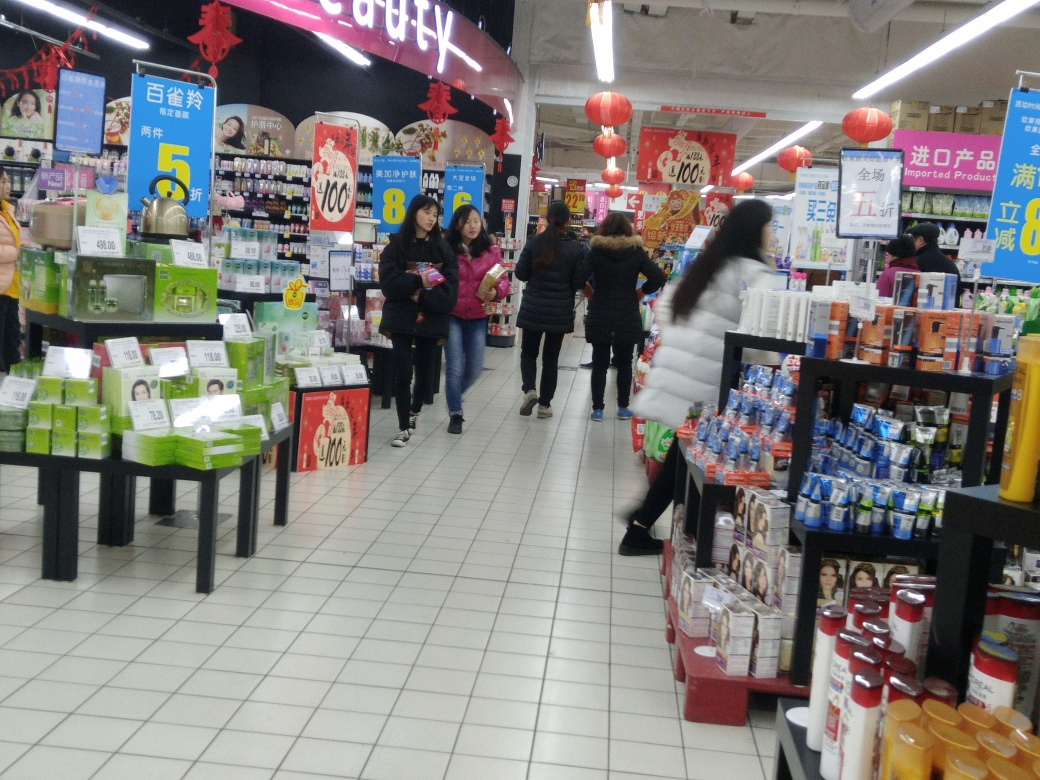Is the image completely free of motion blur? Upon close examination, the image does show slight signs of motion blur, particularly around moving subjects such as the people walking through the store aisles. This suggests a lower shutter speed was used when capturing the photograph, allowing for some movement to be recorded as blur. 